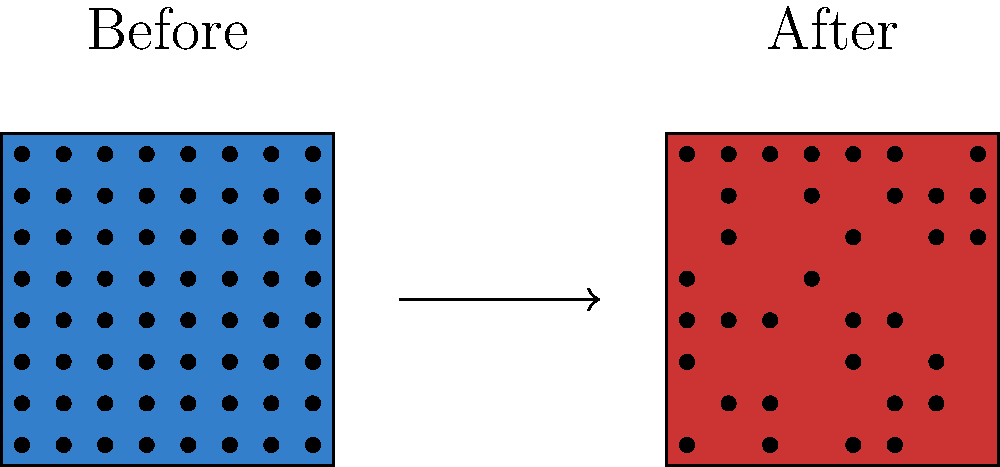In the context of block ciphers, explain how the avalanche effect contributes to the security of an encryption algorithm. Using the provided illustration, describe the expected change in the ciphertext when a single bit is flipped in the plaintext or key. How does this property make the cipher more resistant to cryptanalysis? The avalanche effect is a crucial property in block ciphers that enhances security. To understand its importance, let's break it down step-by-step:

1. Definition: The avalanche effect occurs when a small change in the input (plaintext or key) results in a significant change in the output (ciphertext).

2. Illustration interpretation:
   - Left box: Represents the initial state of the ciphertext.
   - Right box: Shows the state after a single bit flip in the input.
   - The dramatic change in the pattern illustrates the avalanche effect.

3. Expected change:
   - Ideally, flipping a single bit should change approximately 50% of the output bits.
   - In the illustration, we see a significant alteration in the bit pattern.

4. Mathematical representation:
   Let $P$ be the plaintext, $K$ be the key, and $E$ be the encryption function.
   For a small change $\Delta P$ in plaintext:
   $$H(E_K(P) \oplus E_K(P \oplus \Delta P)) \approx \frac{n}{2}$$
   Where $H$ is the Hamming distance, $n$ is the block size, and $\oplus$ is bitwise XOR.

5. Security implications:
   a) Diffusion: Ensures that the statistical properties of the plaintext are dissipated into long-range statistics of the ciphertext.
   b) Confusion: Makes the relationship between the key and ciphertext as complex as possible.

6. Resistance to cryptanalysis:
   a) Differential cryptanalysis becomes more difficult as small input changes cause unpredictable large output changes.
   b) Statistical attacks are thwarted as patterns in the plaintext are effectively masked.
   c) Known-plaintext attacks are less effective as small changes in the key or plaintext produce vastly different ciphertexts.

7. Design considerations:
   Cryptographers aim to maximize the avalanche effect through:
   - Multiple rounds of substitution and permutation
   - Carefully designed S-boxes
   - Proper key scheduling algorithms

By ensuring a strong avalanche effect, the block cipher becomes more robust against various forms of cryptanalysis, significantly enhancing its overall security.
Answer: The avalanche effect causes small input changes to result in significant output changes, enhancing security by increasing diffusion and confusion, thus making the cipher more resistant to various cryptanalytic attacks. 